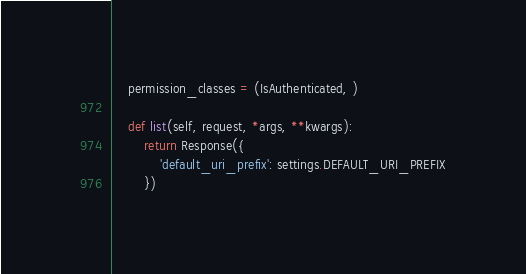Convert code to text. <code><loc_0><loc_0><loc_500><loc_500><_Python_>    permission_classes = (IsAuthenticated, )

    def list(self, request, *args, **kwargs):
        return Response({
            'default_uri_prefix': settings.DEFAULT_URI_PREFIX
        })
</code> 